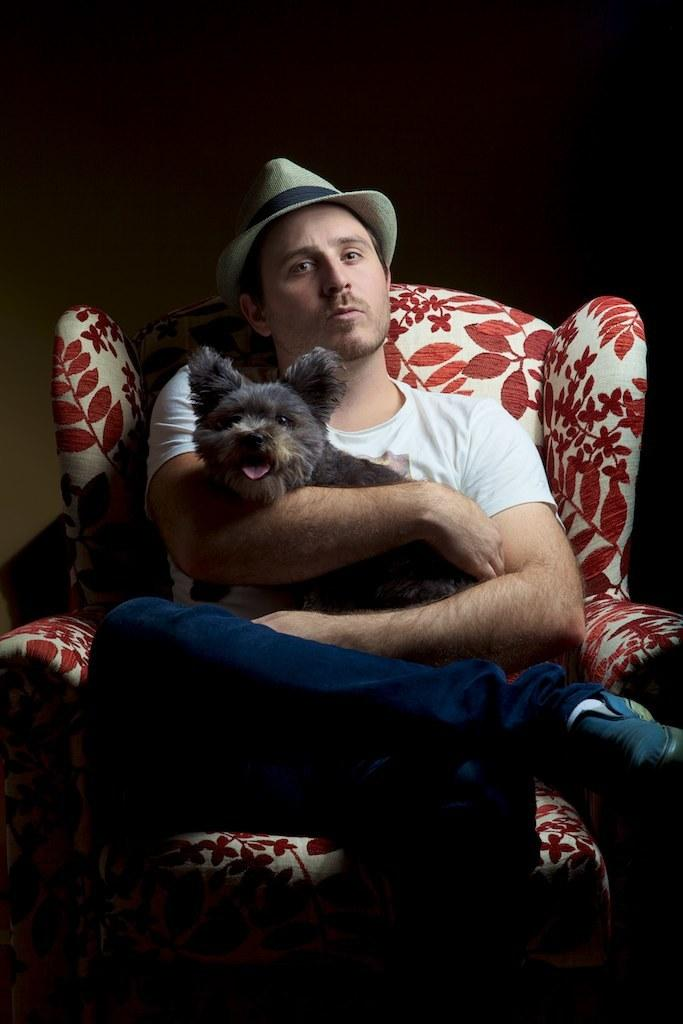What is the main subject of the image? There is a person in the image. What is the person doing in the image? The person is sitting on a chair. Is there any interaction between the person and an animal in the image? Yes, the person is holding a dog in his hand. What type of banana is the person eating in the image? There is no banana present in the image; the person is holding a dog. Is the person paying taxes while sitting on the chair in the image? There is no information about taxes in the image; it only shows a person sitting on a chair and holding a dog. 